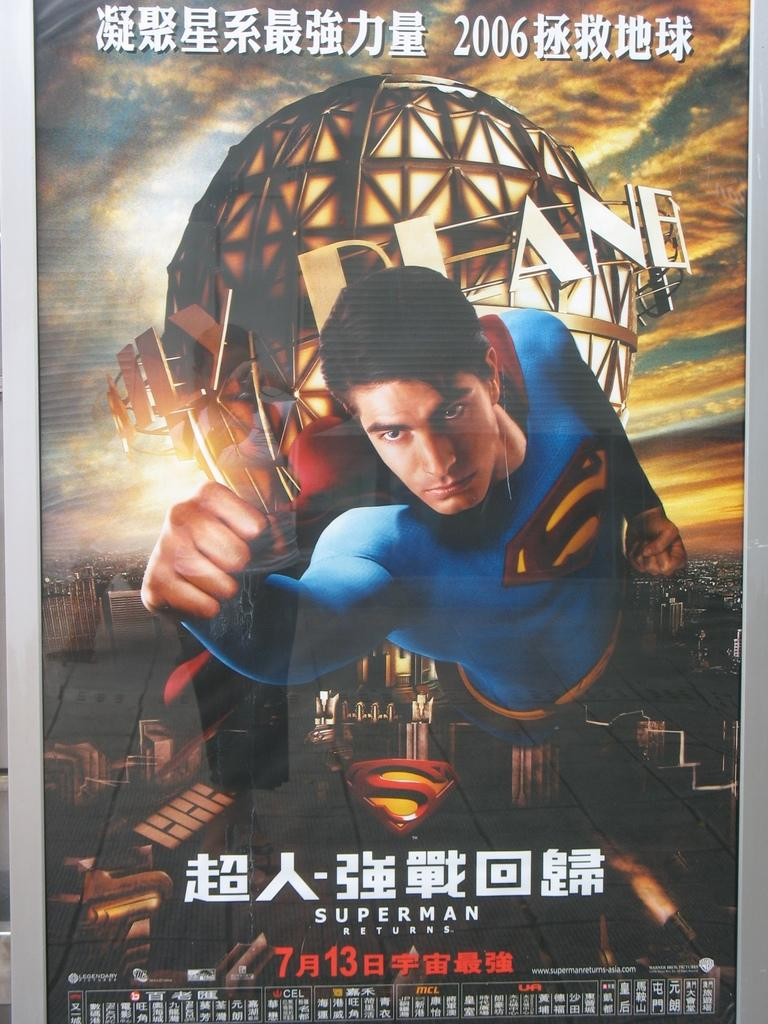<image>
Provide a brief description of the given image. A poster in Chinese advertising the movie Superman Returns. 